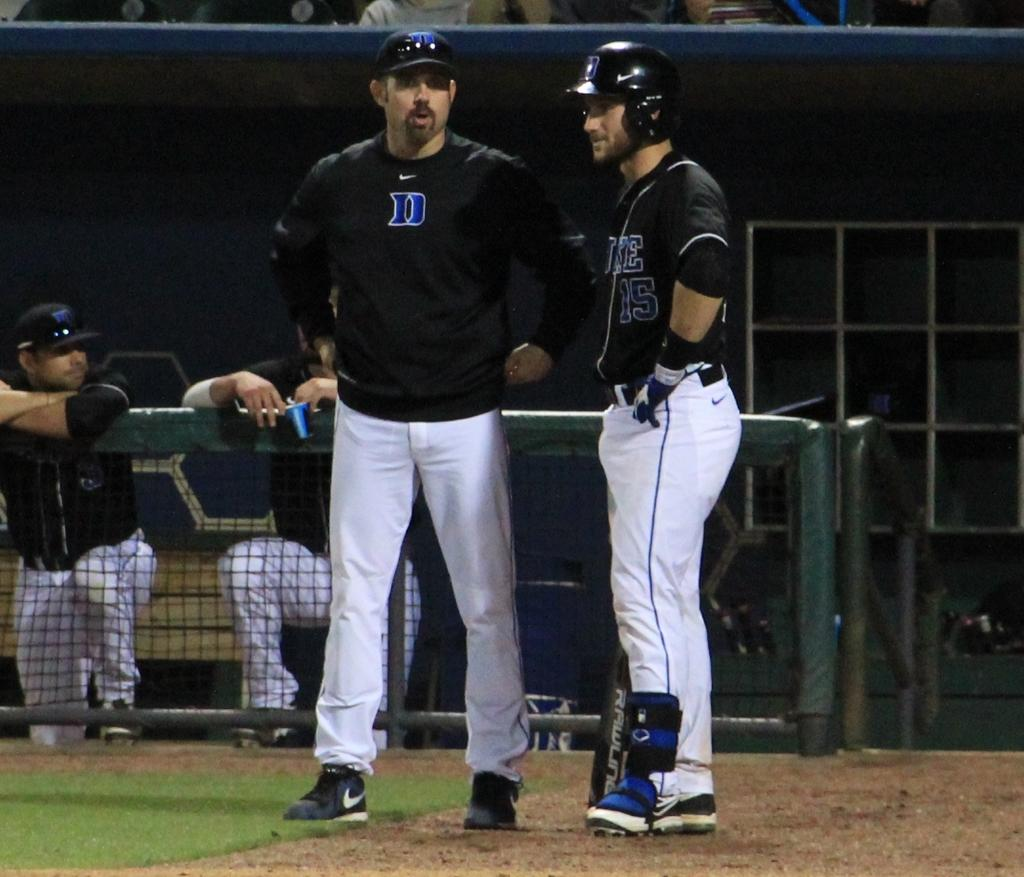<image>
Render a clear and concise summary of the photo. Several players for the Duke baseball team chat while on their field near the dugout. 